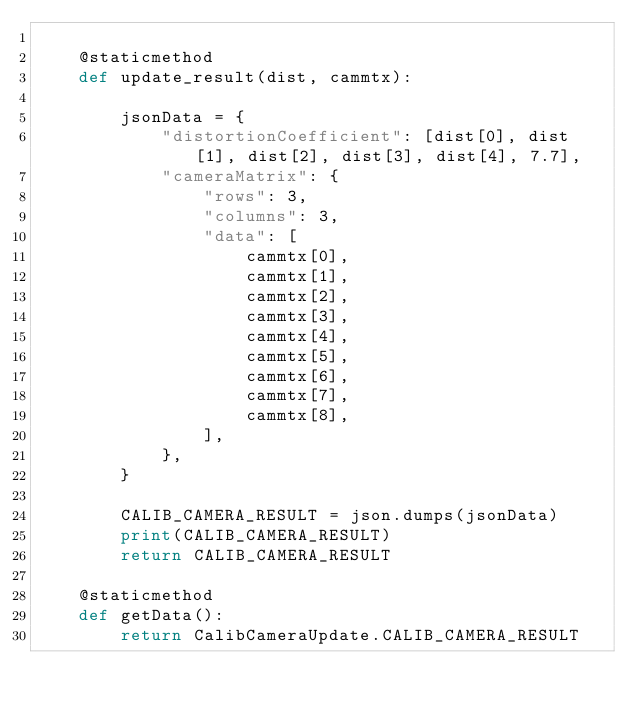<code> <loc_0><loc_0><loc_500><loc_500><_Python_>
    @staticmethod
    def update_result(dist, cammtx):

        jsonData = {
            "distortionCoefficient": [dist[0], dist[1], dist[2], dist[3], dist[4], 7.7],
            "cameraMatrix": {
                "rows": 3,
                "columns": 3,
                "data": [
                    cammtx[0],
                    cammtx[1],
                    cammtx[2],
                    cammtx[3],
                    cammtx[4],
                    cammtx[5],
                    cammtx[6],
                    cammtx[7],
                    cammtx[8],
                ],
            },
        }

        CALIB_CAMERA_RESULT = json.dumps(jsonData)
        print(CALIB_CAMERA_RESULT)
        return CALIB_CAMERA_RESULT

    @staticmethod
    def getData():
        return CalibCameraUpdate.CALIB_CAMERA_RESULT
</code> 